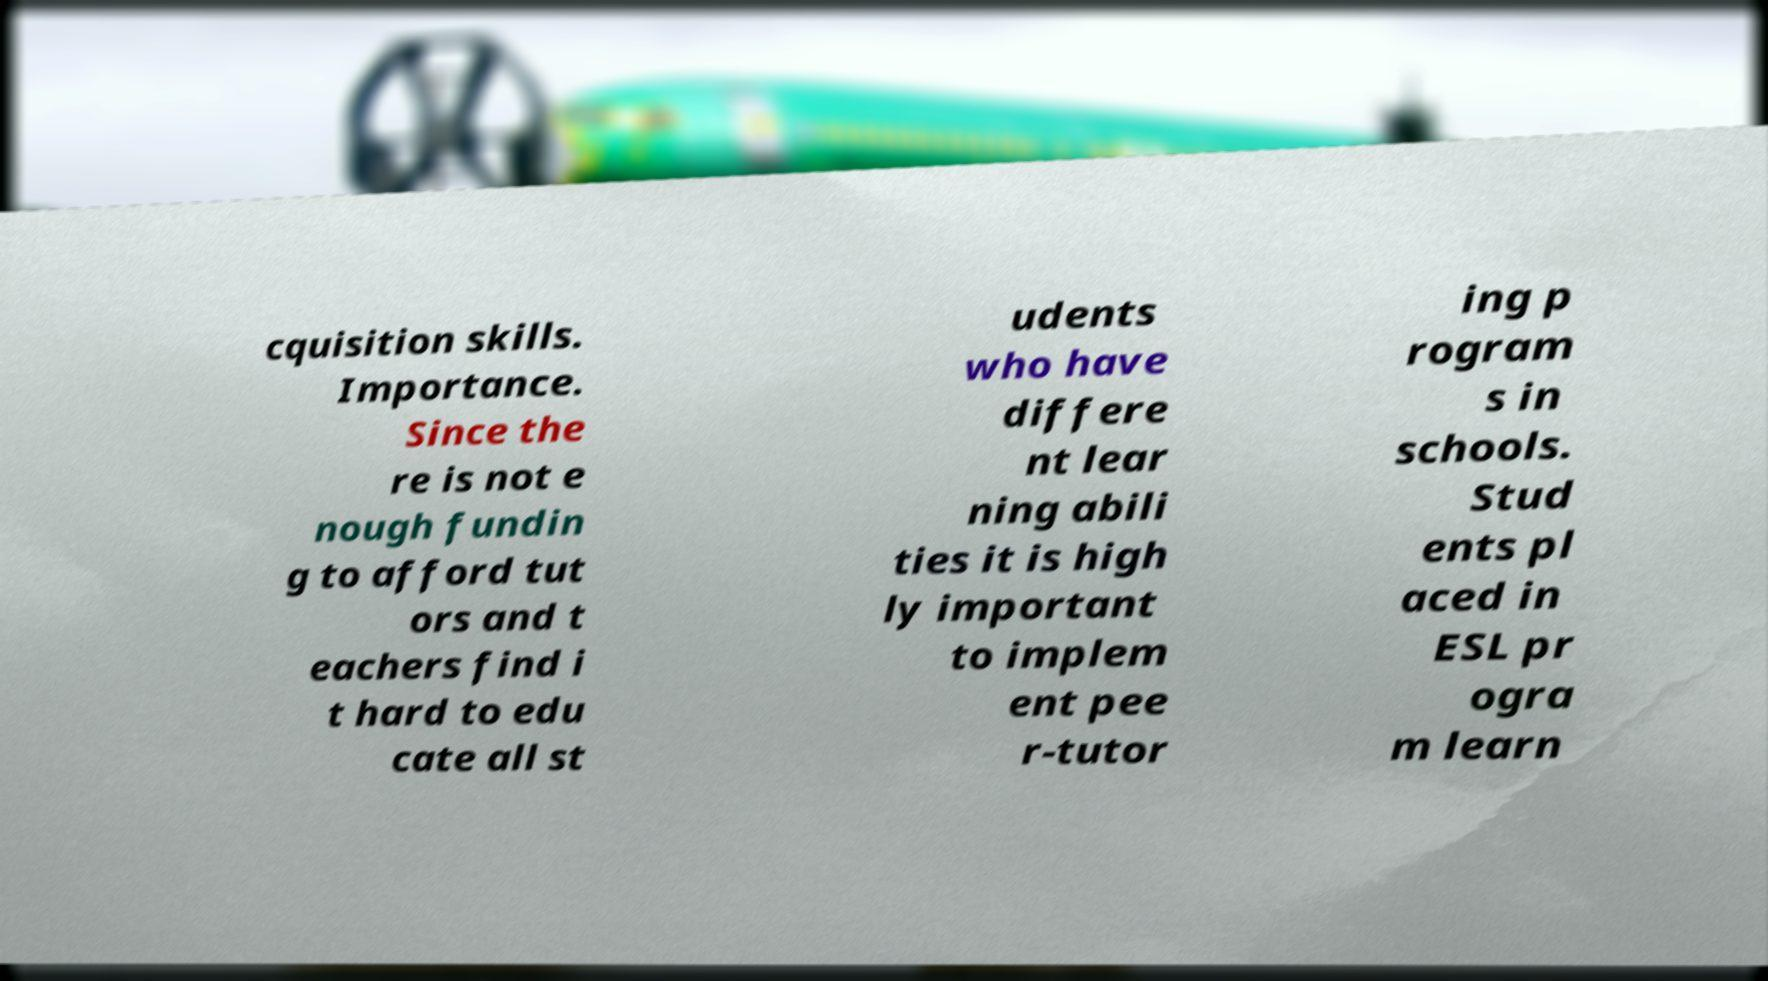Could you assist in decoding the text presented in this image and type it out clearly? cquisition skills. Importance. Since the re is not e nough fundin g to afford tut ors and t eachers find i t hard to edu cate all st udents who have differe nt lear ning abili ties it is high ly important to implem ent pee r-tutor ing p rogram s in schools. Stud ents pl aced in ESL pr ogra m learn 